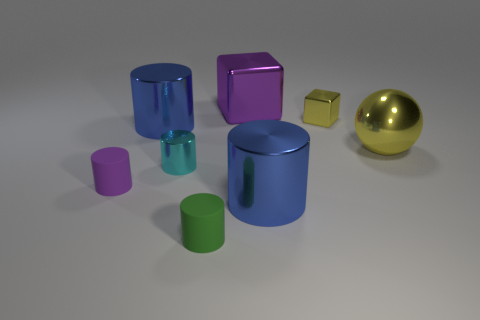Subtract all tiny green matte cylinders. How many cylinders are left? 4 Subtract all green cylinders. How many cylinders are left? 4 Subtract all brown cylinders. Subtract all yellow balls. How many cylinders are left? 5 Add 2 cyan rubber things. How many objects exist? 10 Subtract all balls. How many objects are left? 7 Subtract 1 purple cubes. How many objects are left? 7 Subtract all tiny metal cubes. Subtract all small metal cylinders. How many objects are left? 6 Add 3 cyan cylinders. How many cyan cylinders are left? 4 Add 2 tiny cyan cylinders. How many tiny cyan cylinders exist? 3 